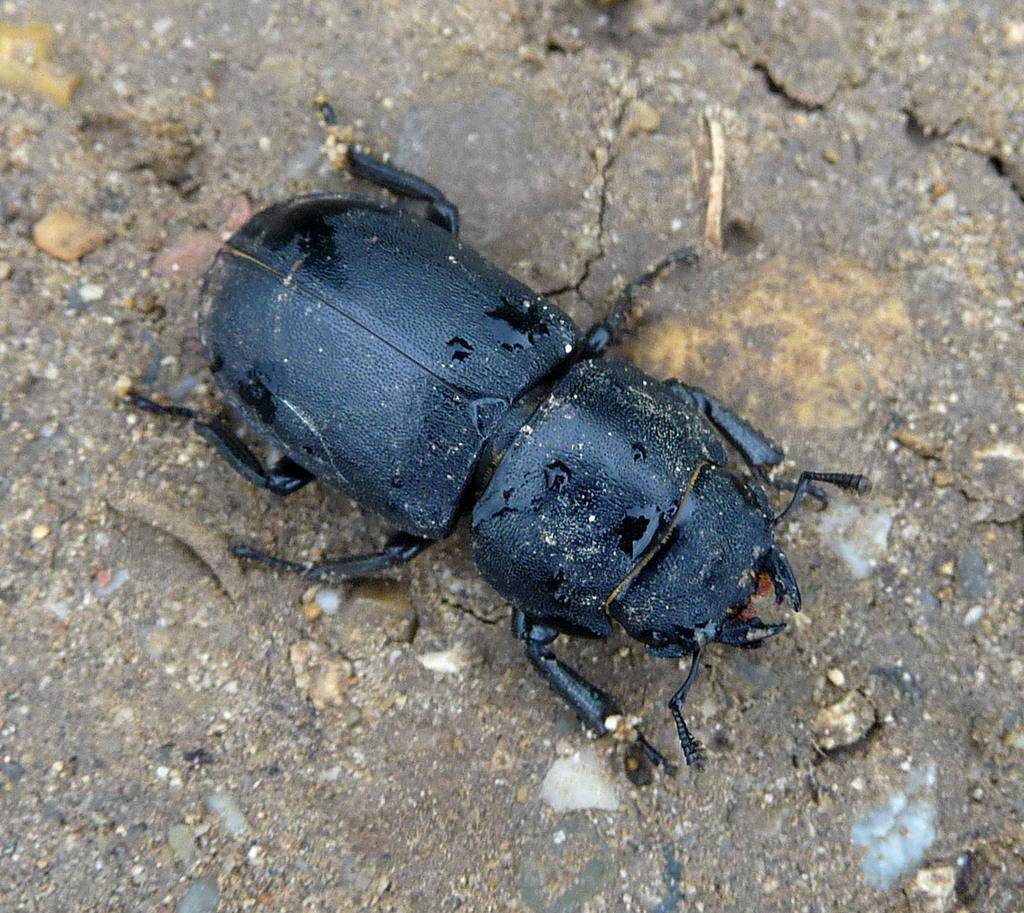What type of creature can be seen in the image? There is an insect in the image. Where is the insect located? The insect is on the land. What color is the insect? The insect is black in color. What type of apple is the insect wearing in the image? There is no apple or vest present in the image, and therefore no such item can be observed. 